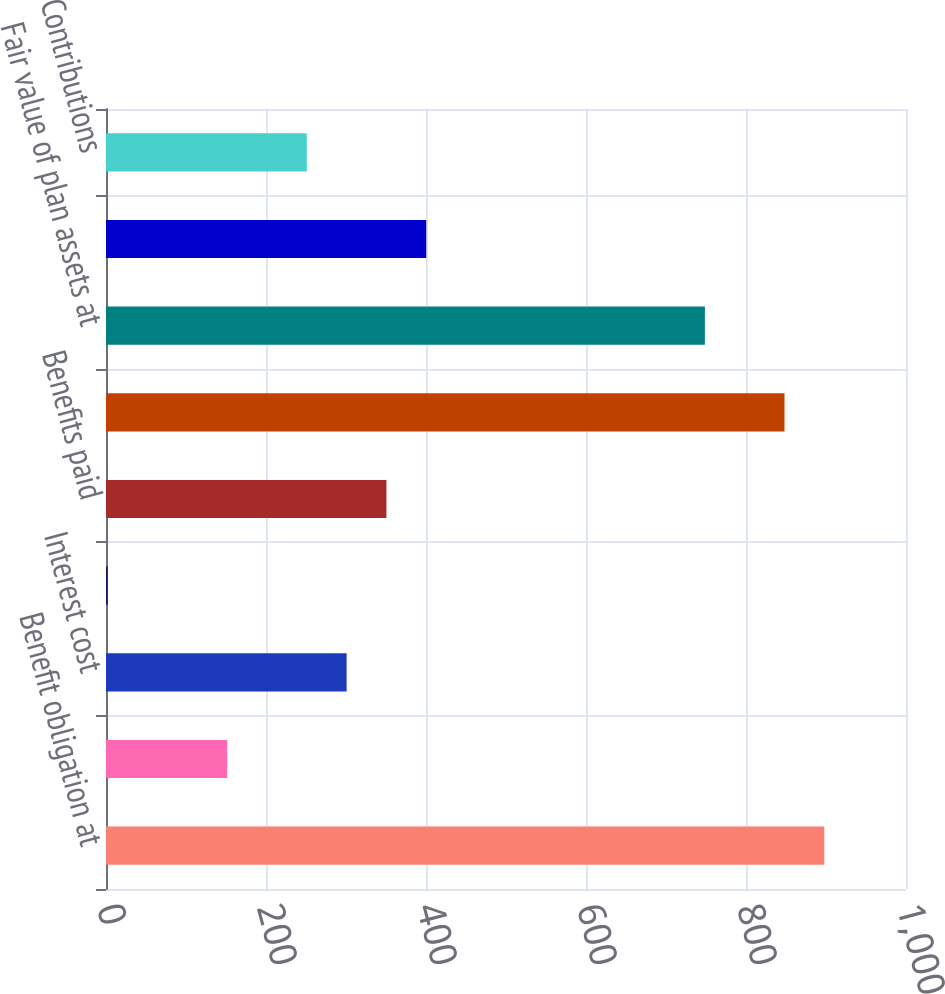Convert chart to OTSL. <chart><loc_0><loc_0><loc_500><loc_500><bar_chart><fcel>Benefit obligation at<fcel>Service cost<fcel>Interest cost<fcel>Actuarial loss (gain)<fcel>Benefits paid<fcel>Benefit obligation at end of<fcel>Fair value of plan assets at<fcel>Actual return on plan assets<fcel>Contributions<nl><fcel>897.88<fcel>151.48<fcel>300.76<fcel>2.2<fcel>350.52<fcel>848.12<fcel>748.6<fcel>400.28<fcel>251<nl></chart> 